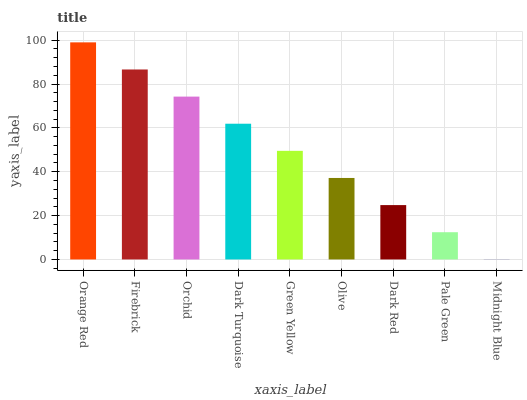Is Midnight Blue the minimum?
Answer yes or no. Yes. Is Orange Red the maximum?
Answer yes or no. Yes. Is Firebrick the minimum?
Answer yes or no. No. Is Firebrick the maximum?
Answer yes or no. No. Is Orange Red greater than Firebrick?
Answer yes or no. Yes. Is Firebrick less than Orange Red?
Answer yes or no. Yes. Is Firebrick greater than Orange Red?
Answer yes or no. No. Is Orange Red less than Firebrick?
Answer yes or no. No. Is Green Yellow the high median?
Answer yes or no. Yes. Is Green Yellow the low median?
Answer yes or no. Yes. Is Midnight Blue the high median?
Answer yes or no. No. Is Olive the low median?
Answer yes or no. No. 